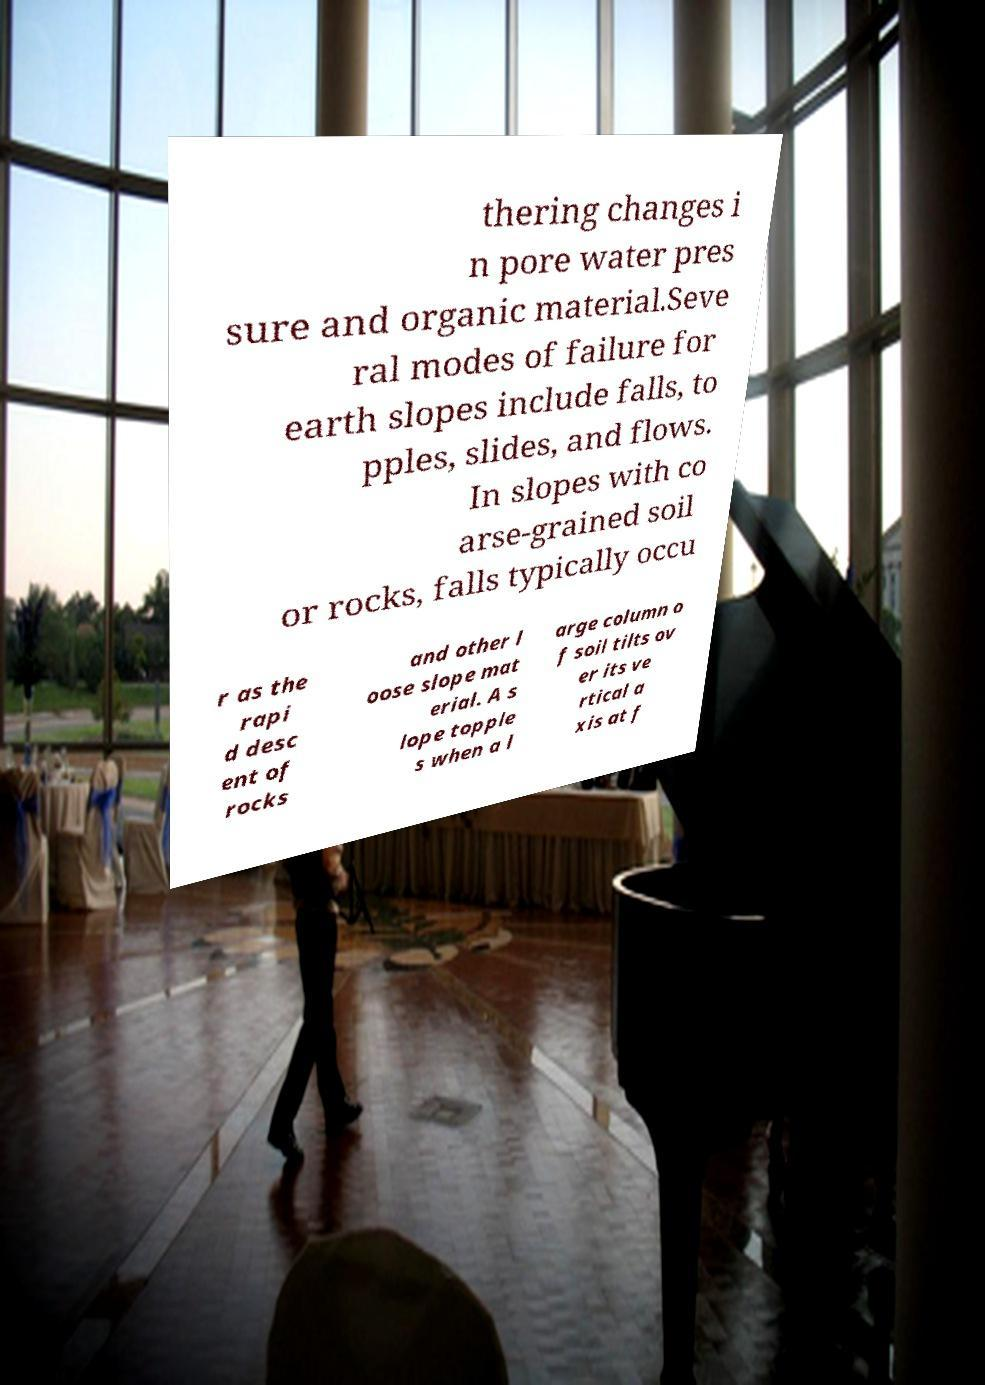Please read and relay the text visible in this image. What does it say? thering changes i n pore water pres sure and organic material.Seve ral modes of failure for earth slopes include falls, to pples, slides, and flows. In slopes with co arse-grained soil or rocks, falls typically occu r as the rapi d desc ent of rocks and other l oose slope mat erial. A s lope topple s when a l arge column o f soil tilts ov er its ve rtical a xis at f 